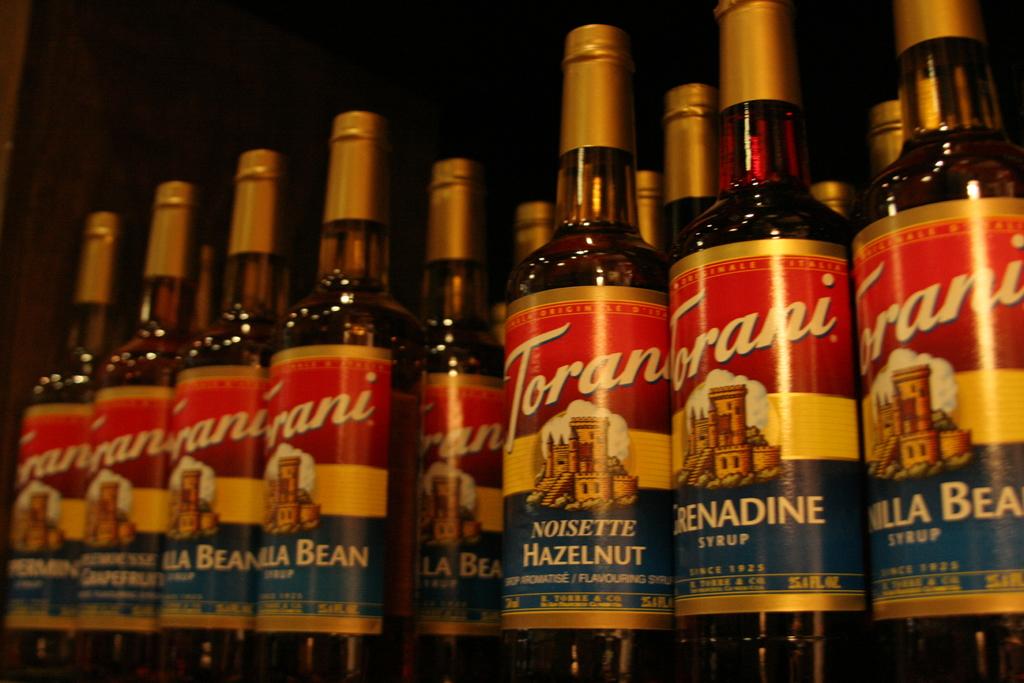Who makes the hazelnut flavored syrup?
Provide a succinct answer. Torani. What is inside these bottles?
Give a very brief answer. Syrup. 